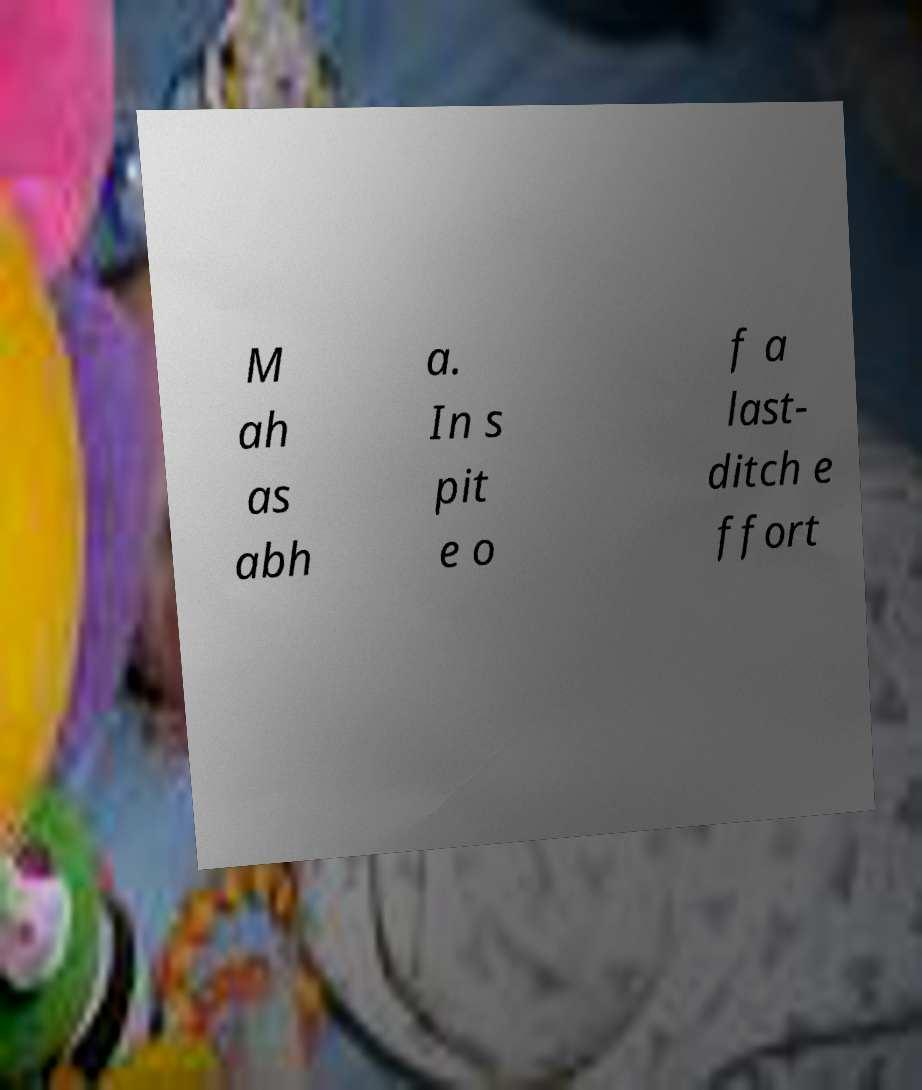Can you accurately transcribe the text from the provided image for me? M ah as abh a. In s pit e o f a last- ditch e ffort 